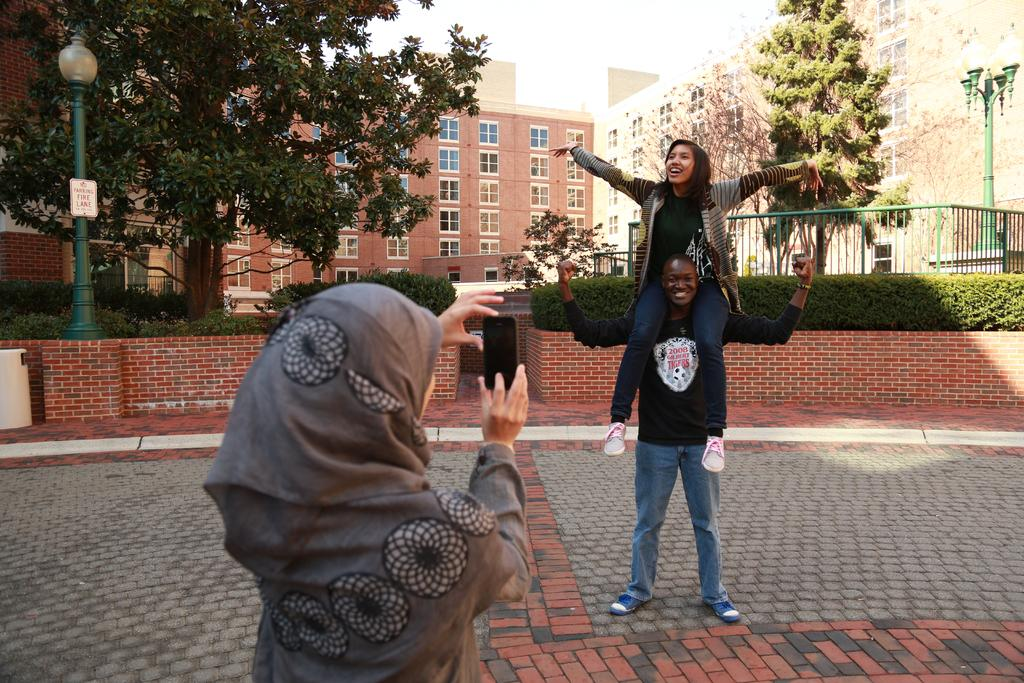What is the man doing in the image? The man is carrying a woman in the image. What is the woman holding in the image? The woman is holding a phone in the image. What type of structures can be seen in the image? There are buildings in the image. What type of vegetation can be seen in the image? There are trees in the image. Where is the mailbox located in the image? There is no mailbox present in the image. What type of chalk is being used to draw on the trees in the image? There is no chalk or drawing on the trees in the image. 